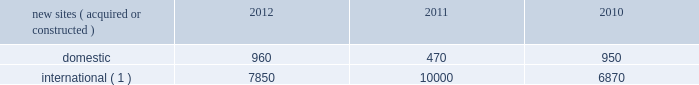Continue to be deployed as wireless service providers are beginning their investments in 3g data networks .
Similarly , in ghana and uganda , wireless service providers continue to build out their voice and data networks in order to satisfy increasing demand for wireless services .
In south africa , where voice networks are in a more advanced stage of development , carriers are beginning to deploy 3g data networks across spectrum acquired in recent spectrum auctions .
In mexico and brazil , where nationwide voice networks have also been deployed , some incumbent wireless service providers continue to invest in their 3g data networks , and recent spectrum auctions have enabled other incumbent wireless service providers to begin their initial investments in 3g data networks .
In markets such as chile , peru and colombia , recent or anticipated spectrum auctions are expected to drive investment in nationwide voice and 3g data networks .
In germany , our most mature international wireless market , demand is currently being driven by a government-mandated rural fourth generation network build-out , as well as other tenant initiatives to deploy next generation wireless services .
We believe incremental demand for our tower sites will continue in our international markets as wireless service providers seek to remain competitive by increasing the coverage of their networks while also investing in next generation data networks .
Rental and management operations new site revenue growth .
During the year ended december 31 , 2012 , we grew our portfolio of communications real estate through acquisitions and construction activities , including the acquisition and construction of approximately 8810 sites .
In a majority of our international markets , the acquisition or construction of new sites results in increased pass-through revenues and expenses .
We continue to evaluate opportunities to acquire larger communications real estate portfolios , both domestically and internationally , to determine whether they meet our risk adjusted hurdle rates and whether we believe we can effectively integrate them into our existing portfolio. .
( 1 ) the majority of sites acquired or constructed in 2012 were in brazil , germany , india and uganda ; in 2011 were in brazil , colombia , ghana , india , mexico and south africa ; and in 2010 were in chile , colombia , india and peru .
Network development services segment revenue growth .
As we continue to focus on growing our rental and management operations , we anticipate that our network development services revenue will continue to represent a relatively small percentage of our total revenues .
Through our network development services segment , we offer tower-related services , including site acquisition , zoning and permitting services and structural analysis services , which primarily support our site leasing business and the addition of new tenants and equipment on our sites , including in connection with provider network upgrades .
Rental and management operations expenses .
Direct operating expenses incurred by our domestic and international rental and management segments include direct site level expenses and consist primarily of ground rent , property taxes , repairs and maintenance , security and power and fuel costs , some of which may be passed through to our tenants .
These segment direct operating expenses exclude all segment and corporate selling , general , administrative and development expenses , which are aggregated into one line item entitled selling , general , administrative and development expense in our consolidated statements of operations .
In general , our domestic and international rental and management segments selling , general , administrative and development expenses do not significantly increase as a result of adding incremental tenants to our legacy sites and typically increase only modestly year-over-year .
As a result , leasing additional space to new tenants on our legacy sites provides significant incremental cash flow .
We may incur additional segment selling , general , administrative and development expenses as we increase our presence in geographic areas where we have recently launched operations or are focused on expanding our portfolio .
Our profit margin growth is therefore positively impacted by the addition of new tenants to our legacy sites and can be temporarily diluted by our development activities. .
In 2012 , what percent of new sites were foreign? 
Rationale: foreign = international
Computations: (7850 / (960 + 7850))
Answer: 0.89103. 